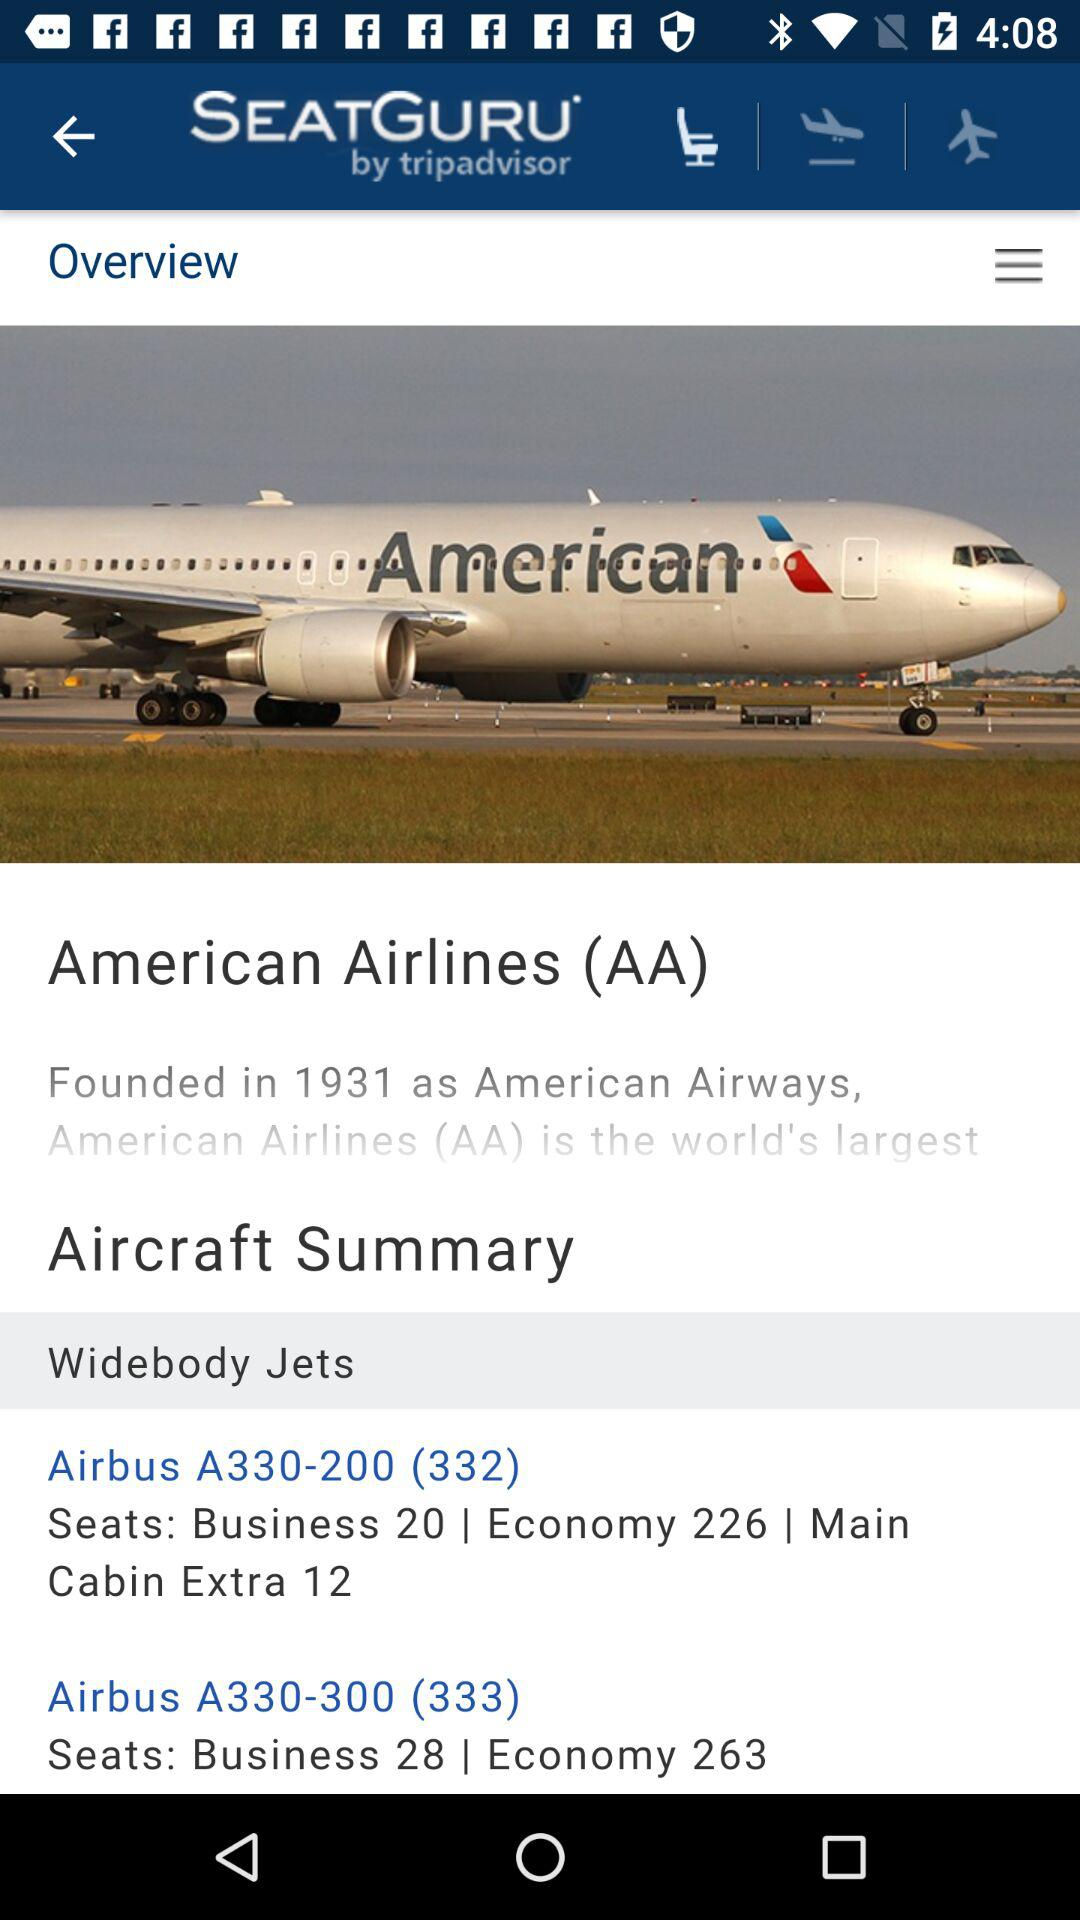What is the number of business seats in the Airbus A330-200 (332)? The number of business seats is 20. 